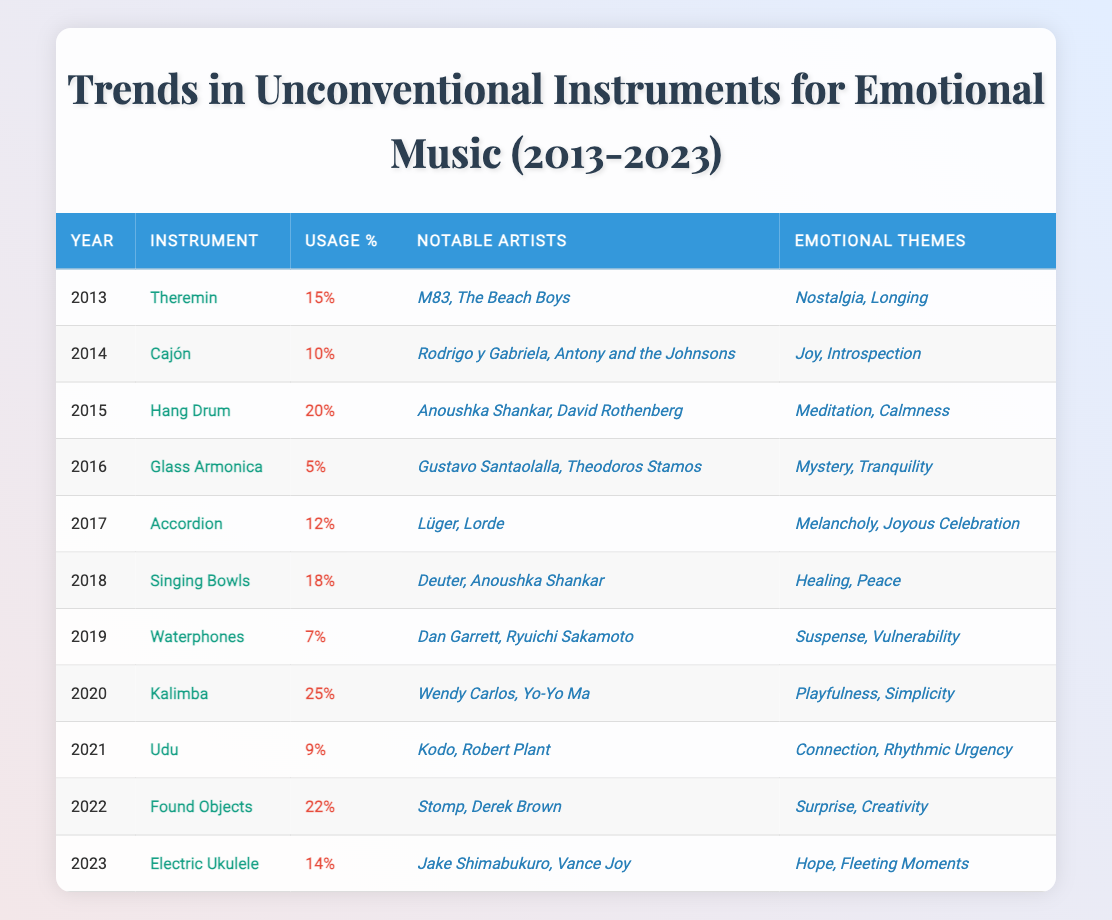What instrument had the highest percentage of use in emotional music compositions in 2020? In 2020, the table indicates that the Kalimba had the highest percentage of use at 25%.
Answer: Kalimba Which emotional theme was associated with the largest number of unconventional instruments in the dataset? By examining the emotional themes, the themes "Joy" and "Healing" are linked to multiple instruments (Cajón, Accordion, Singing Bowls; Healing being linked only to Singing Bowls). Thus, "Joy" is associated with 3 instruments while "Healing" is associated with 1, making "Joy" the most represented theme.
Answer: Joy What is the average percentage of use for all instruments listed from 2013 to 2023? The total percentage of use from all years is 15 + 10 + 20 + 5 + 12 + 18 + 7 + 25 + 9 + 22 + 14 =  165. There are 11 years, so the average is 165 divided by 11, which is approximately 15. Therefore, the average percentage of use is around 15%.
Answer: 15% Did the use of the Glass Armonica increase over the years from 2013 to 2023? According to the data, the Glass Armonica had a percentage of use of 5% in 2016, and there are no later entries for this instrument; hence, its use did not increase after 2016.
Answer: No Which instrument was used most frequently in emotional music compositions between 2018 and 2023? The numbers from the years 2018 to 2023 show the following percentages: Singing Bowls 18%, Kalimba 25%, Udu 9%, Found Objects 22%, Electric Ukulele 14%. The highest usage in this timeframe was 25% for the Kalimba.
Answer: Kalimba What emotional theme is associated with the Accordion instrument used in 2017? Looking at the data for 2017, the Accordion is associated with "Melancholy" and "Joyous Celebration."
Answer: Melancholy, Joyous Celebration Was the usage of unconventional instruments higher in 2018 or 2023? The percentage of use for 2018 is 18% (Singing Bowls), while for 2023 it is 14% (Electric Ukulele). Since 18% is greater than 14%, the usage in 2018 was higher.
Answer: 2018 Which two years saw a notable focus on "Healing" and "Nostalgia" emotional themes respectively? The emotional theme "Healing" is specifically associated with the Singing Bowls in 2018, while "Nostalgia" is linked with the Theremin in 2013. Therefore, the years to note are 2018 for Healing and 2013 for Nostalgia.
Answer: 2013, 2018 